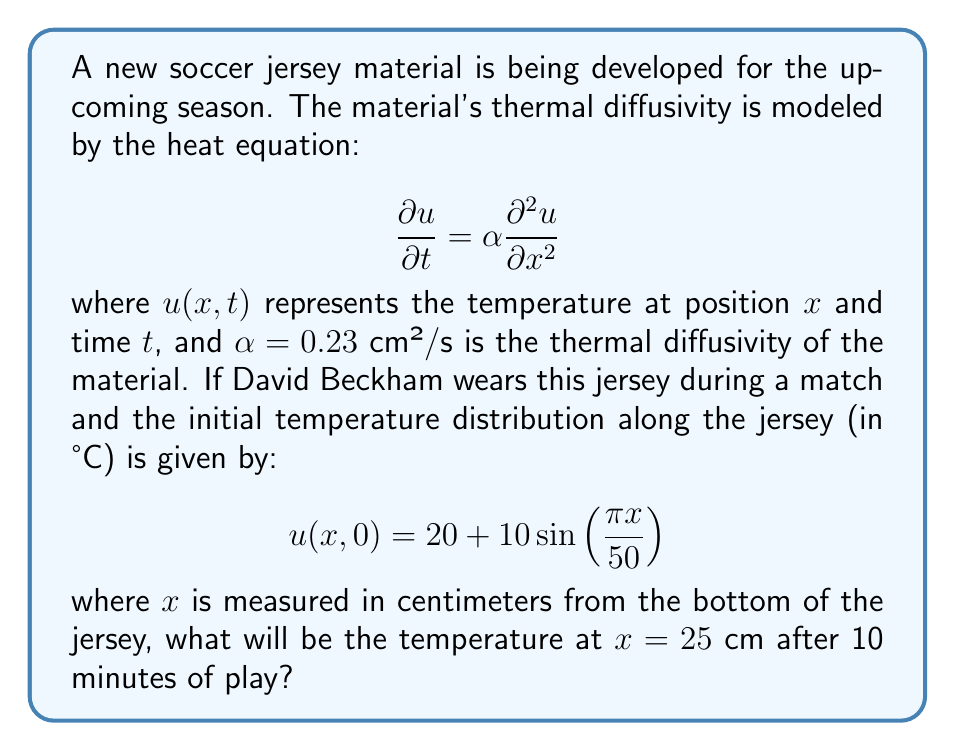What is the answer to this math problem? To solve this problem, we'll use the method of separation of variables for the heat equation.

Step 1: Separate the variables
Let $u(x,t) = X(x)T(t)$. Substituting this into the heat equation:

$$X(x)T'(t) = \alpha X''(x)T(t)$$

$$\frac{T'(t)}{T(t)} = \alpha \frac{X''(x)}{X(x)} = -\lambda$$

where $\lambda$ is a constant.

Step 2: Solve the spatial equation
$$X''(x) + \frac{\lambda}{\alpha}X(x) = 0$$

The general solution is:
$$X(x) = A\cos(\sqrt{\frac{\lambda}{\alpha}}x) + B\sin(\sqrt{\frac{\lambda}{\alpha}}x)$$

Step 3: Apply boundary conditions
The initial condition gives us:
$$u(x,0) = 20 + 10\sin(\frac{\pi x}{50})$$

This means we need $\sqrt{\frac{\lambda}{\alpha}} = \frac{\pi}{50}$, or $\lambda = \frac{\alpha \pi^2}{2500}$.

Step 4: Solve the time equation
$$T'(t) + \lambda T(t) = 0$$
$$T(t) = Ce^{-\lambda t} = Ce^{-\frac{\alpha \pi^2}{2500}t}$$

Step 5: Combine the solutions
$$u(x,t) = 20 + 10\sin(\frac{\pi x}{50})e^{-\frac{\alpha \pi^2}{2500}t}$$

Step 6: Calculate the temperature at $x = 25$ cm and $t = 600$ s (10 minutes)
$$u(25,600) = 20 + 10\sin(\frac{\pi 25}{50})e^{-\frac{0.23 \pi^2}{2500}600}$$
$$= 20 + 10\sin(\frac{\pi}{2})e^{-0.0069 \pi^2}$$
$$= 20 + 10 \cdot 1 \cdot 0.5026$$
$$= 25.026°C$$
Answer: 25.026°C 